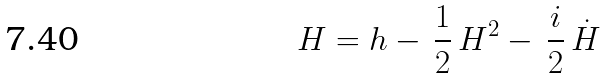Convert formula to latex. <formula><loc_0><loc_0><loc_500><loc_500>H = h - \, \frac { 1 } { 2 } \, H ^ { 2 } - \, \frac { i } { 2 } \, \dot { H }</formula> 